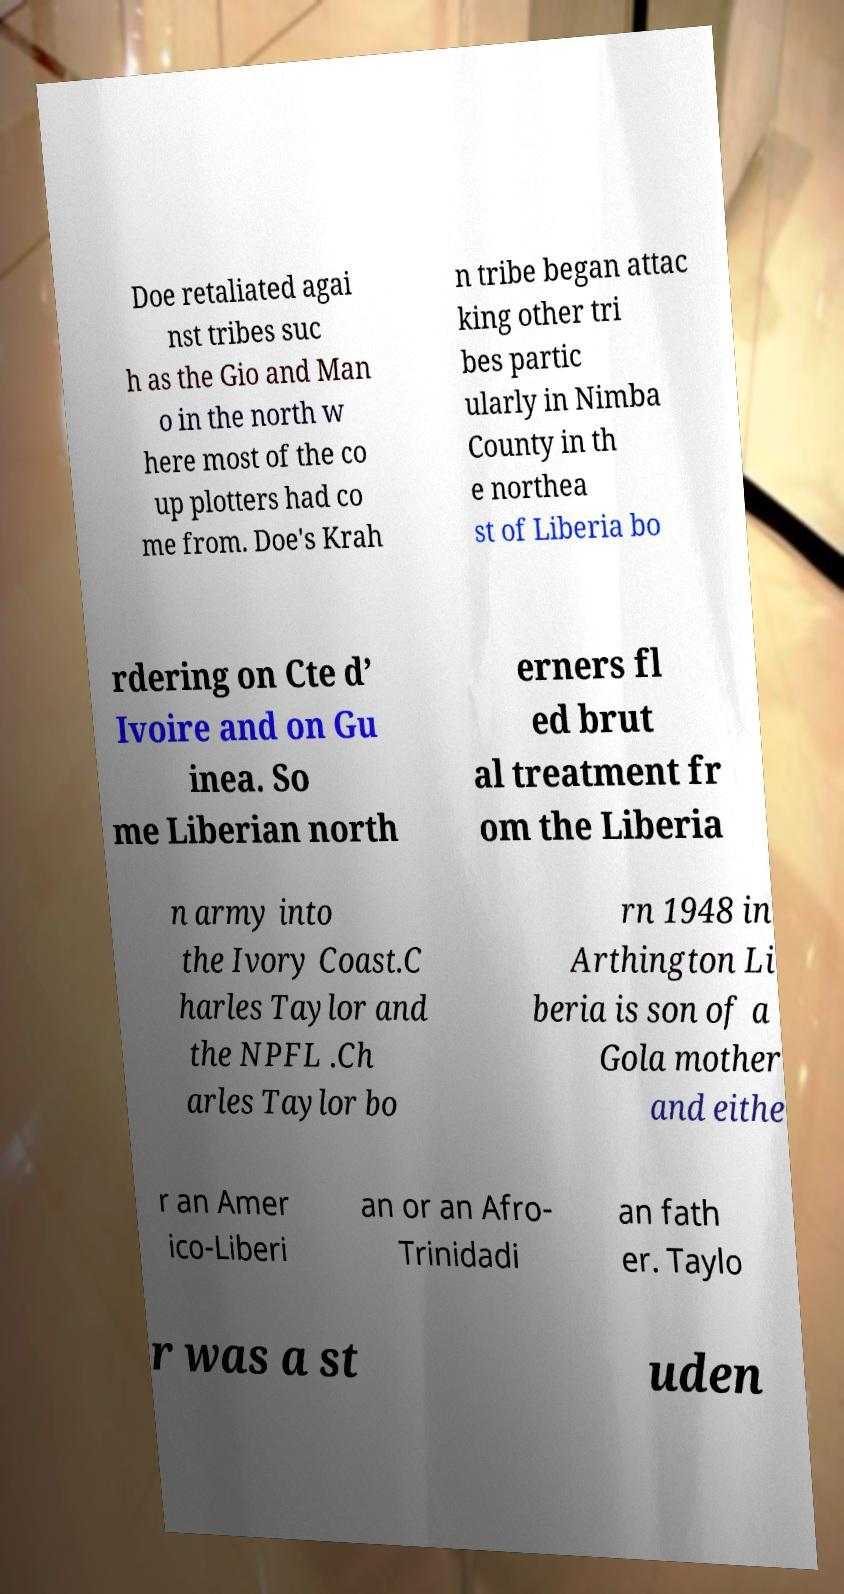For documentation purposes, I need the text within this image transcribed. Could you provide that? Doe retaliated agai nst tribes suc h as the Gio and Man o in the north w here most of the co up plotters had co me from. Doe's Krah n tribe began attac king other tri bes partic ularly in Nimba County in th e northea st of Liberia bo rdering on Cte d’ Ivoire and on Gu inea. So me Liberian north erners fl ed brut al treatment fr om the Liberia n army into the Ivory Coast.C harles Taylor and the NPFL .Ch arles Taylor bo rn 1948 in Arthington Li beria is son of a Gola mother and eithe r an Amer ico-Liberi an or an Afro- Trinidadi an fath er. Taylo r was a st uden 